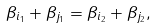Convert formula to latex. <formula><loc_0><loc_0><loc_500><loc_500>\beta _ { i _ { 1 } } + \beta _ { j _ { 1 } } = \beta _ { i _ { 2 } } + \beta _ { j _ { 2 } } ,</formula> 